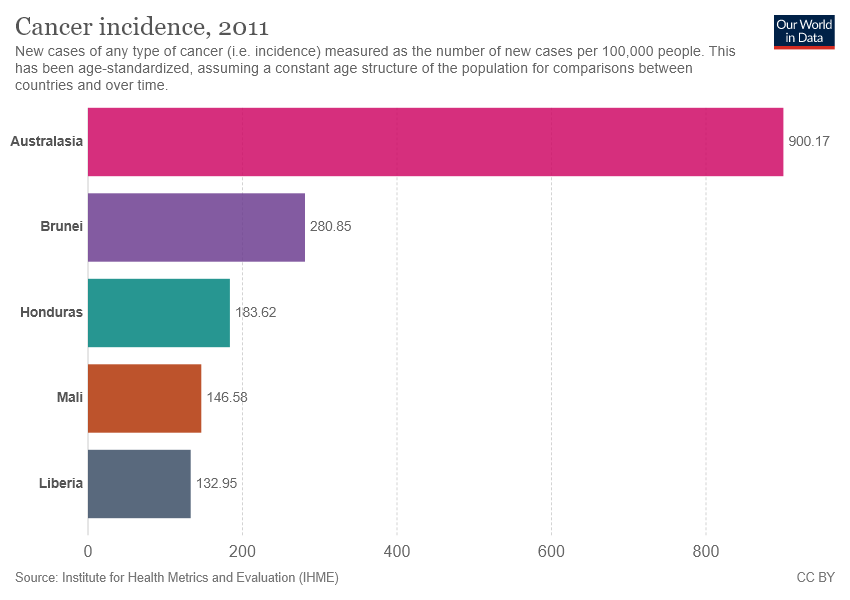Draw attention to some important aspects in this diagram. No, the sum of the two lowest cancer incidence rates is not higher than Brunei. There are five colors displayed in the graph. 